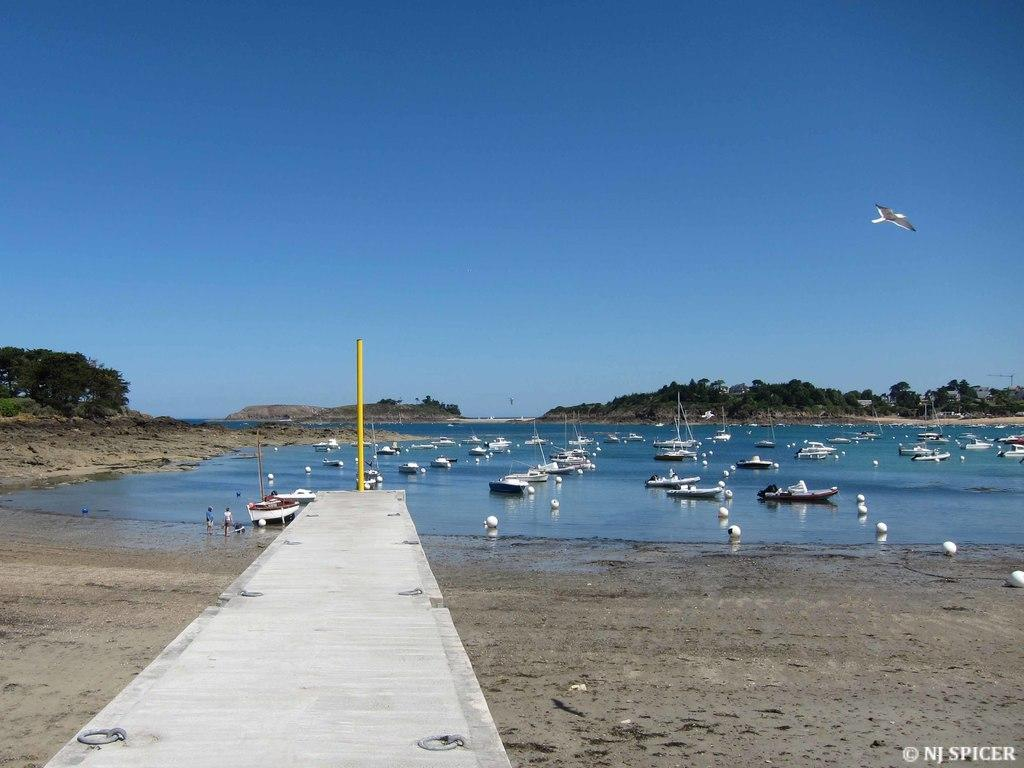What can be seen in the image that is used for transportation on water? There are boats in the image. Where are the boats located? The boats are in a river. What else can be seen in the image besides the boats? There is a path in the image. What is visible in the background of the image? There are mountains, trees, and a blue sky in the background of the image. What type of pen is being used to draw the mountains in the image? There is no pen or drawing activity present in the image; it is a photograph of a river with boats, a path, and a background of mountains, trees, and a blue sky. 